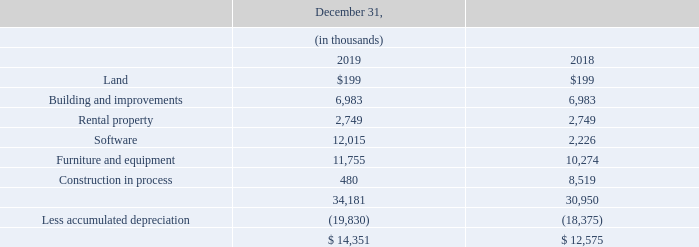Note 8 — Property, Plant and Equipment, net
The components of property, plant and equipment, net, are:
The estimated useful lives of buildings and improvements and rental property are twenty to twenty-five years. The estimated useful lives of furniture and equipment range from three to eight years. Depreciation expense from continuing operations was $1.5 million and $1.2 million for 2019 and 2018, respectively.
The Company leases a portion of its headquarters facility to various tenants. Net rent received from these leases totaled $0.3 million and $0.4 million for 2019 and 2018, respectively.
What is the estimated useful lives of furniture and equipment? Range from three to eight years. What was the Depreciation expense from continuing operations for 2019 and 2018 respectively? $1.5 million, $1.2 million. How much was the Net rent received from leases for 2019 and 2018 respectively? $0.3 million, $0.4 million. What is the change in Furniture and equipment between December 31, 2018 and 2019?
Answer scale should be: thousand. 11,755-10,274
Answer: 1481. What is the change in accumulated depreciation between December 31, 2018 and 2019?
Answer scale should be: thousand. 19,830-18,375
Answer: 1455. What is the average Furniture and equipment for December 31, 2018 and 2019?
Answer scale should be: thousand. (11,755+10,274) / 2
Answer: 11014.5. 